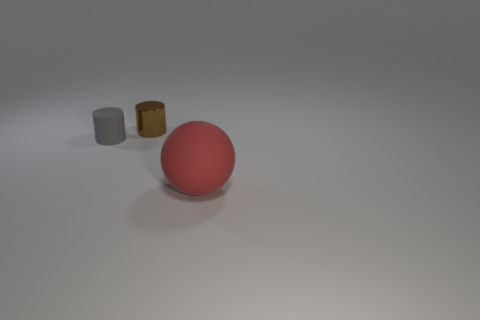How many brown things are behind the tiny cylinder that is to the right of the rubber thing that is left of the red rubber thing?
Keep it short and to the point. 0. How many shiny things are either small brown objects or small blue cylinders?
Make the answer very short. 1. There is a thing that is on the left side of the small object that is behind the small matte object; how big is it?
Your answer should be very brief. Small. Is the color of the tiny cylinder that is in front of the brown metal cylinder the same as the matte object that is right of the tiny metallic thing?
Make the answer very short. No. The thing that is in front of the tiny brown shiny cylinder and to the right of the small gray matte cylinder is what color?
Make the answer very short. Red. Are the small gray thing and the brown cylinder made of the same material?
Give a very brief answer. No. What number of big things are brown matte spheres or rubber things?
Provide a short and direct response. 1. Is there any other thing that is the same shape as the brown metallic thing?
Provide a succinct answer. Yes. Is there anything else that is the same size as the metal thing?
Provide a succinct answer. Yes. The big ball that is the same material as the small gray thing is what color?
Keep it short and to the point. Red. 